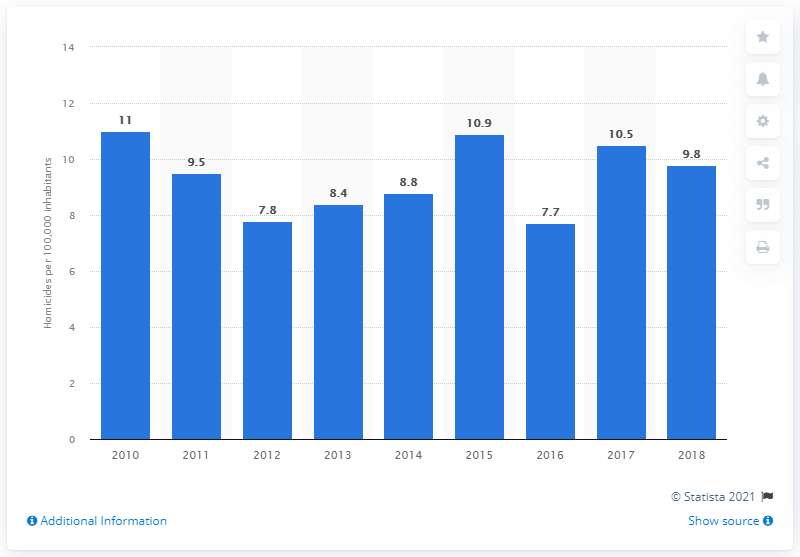Specify some key components in this picture. The previous year's homicide rate in Barbados was 10.5. 